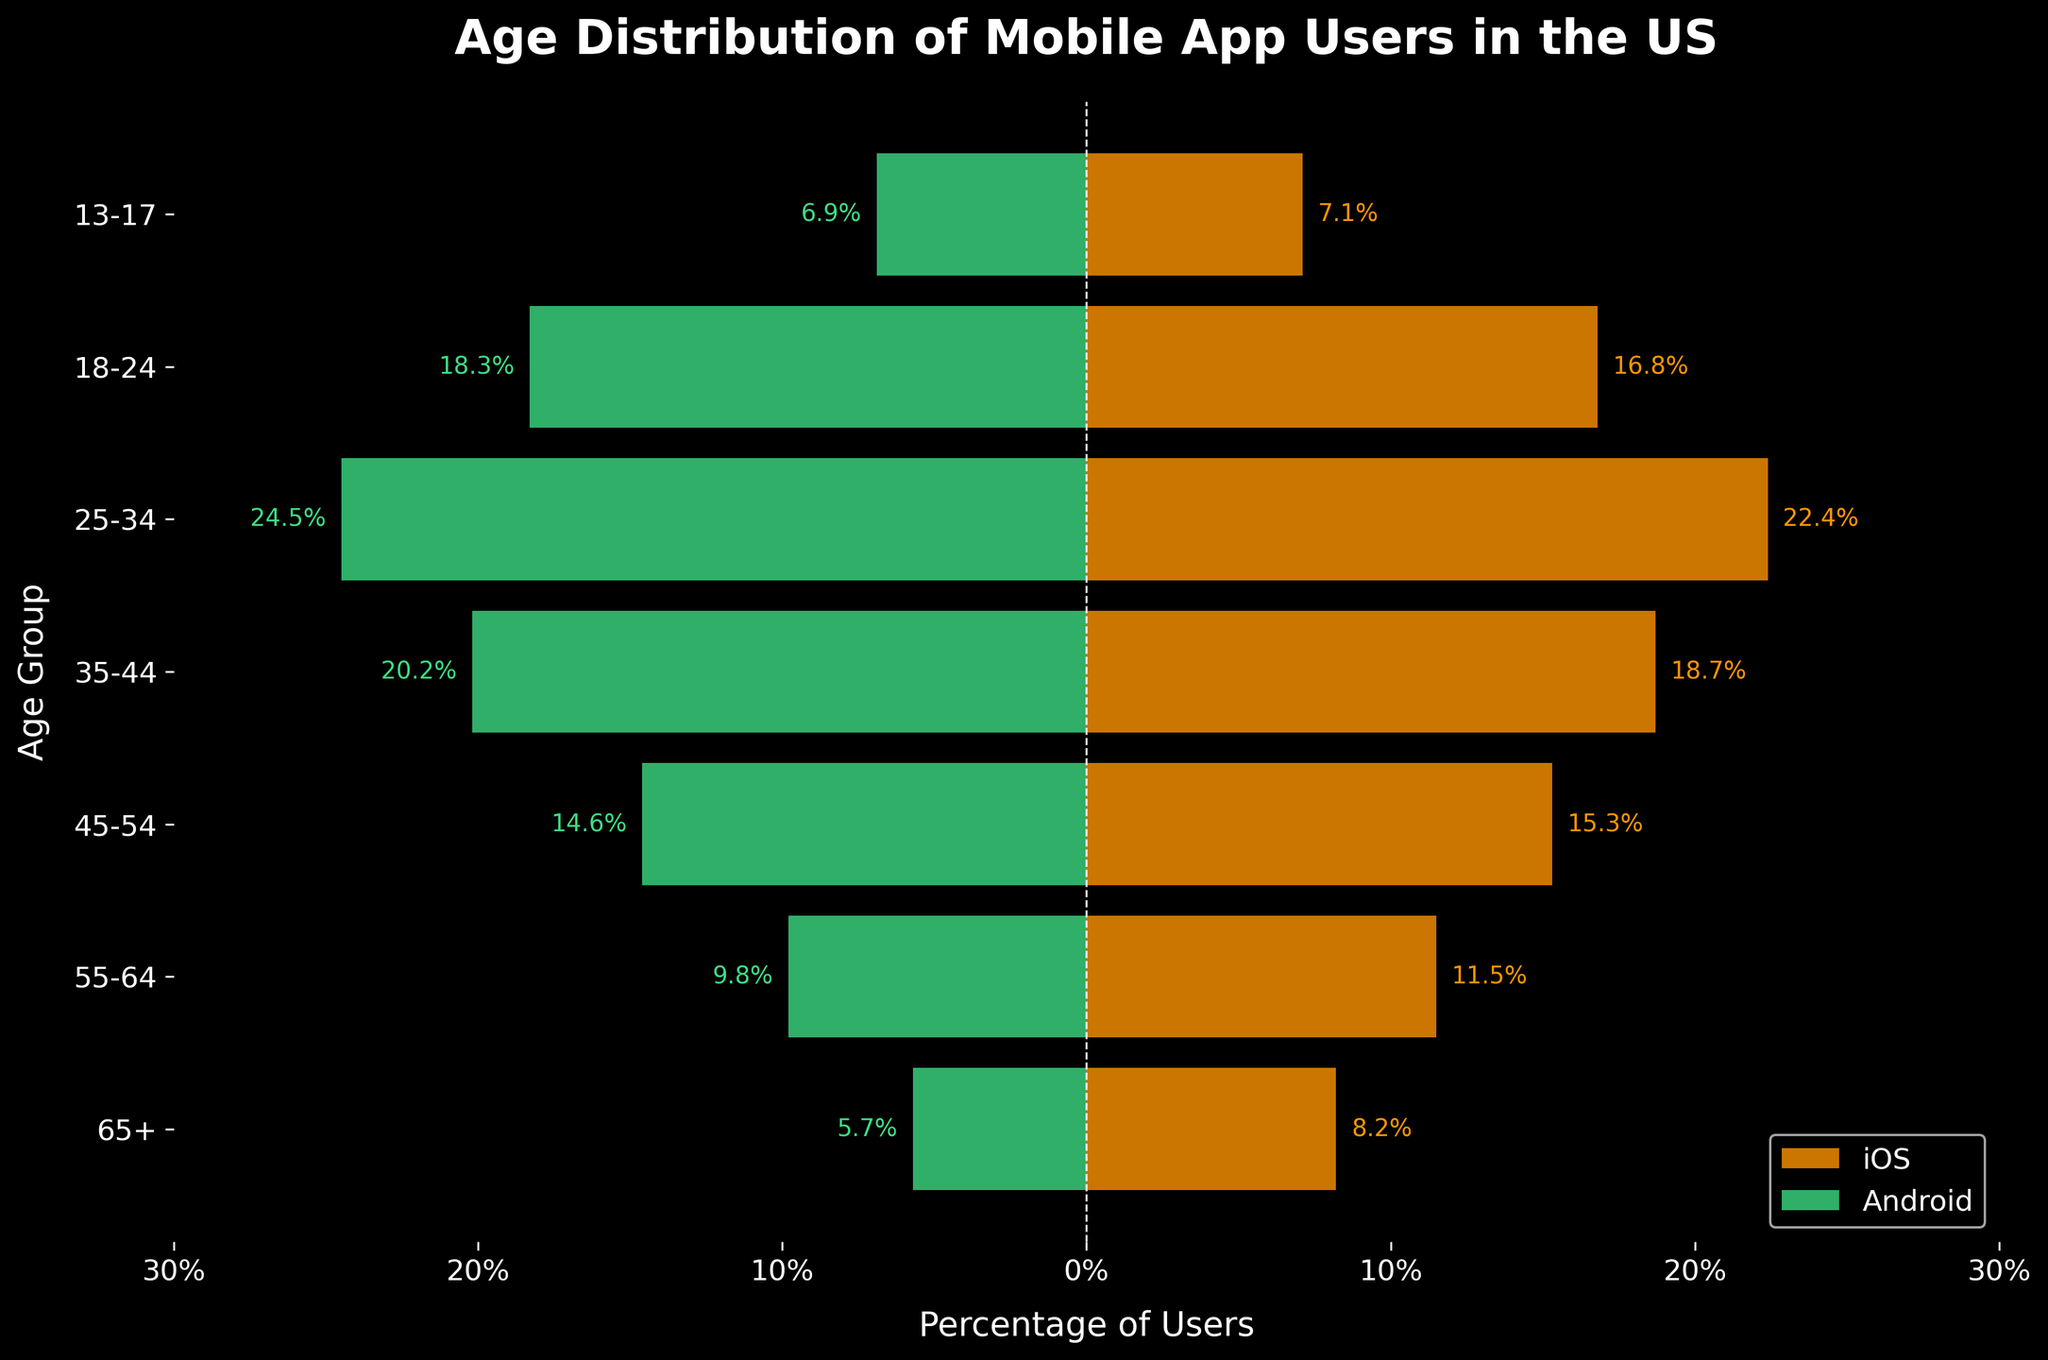What is the title of the plot? The title of the plot is usually displayed at the top of the figure. In this case, we see "Age Distribution of Mobile App Users in the US" at the top in a bold font.
Answer: Age Distribution of Mobile App Users in the US Which age group has the highest percentage of iOS users? By looking at the orange bars representing iOS users, the longest bar corresponds to the "25-34" age group, indicating it has the highest percentage.
Answer: 25-34 How does the percentage of Android users in the "18-24" age group compare to iOS users in the same group? The green bar for Android users in the "18-24" age group is slightly longer than the orange bar for iOS users, indicating a higher percentage of Android users in this group.
Answer: Android users have a higher percentage What is the percentage difference between iOS and Android users in the "55-64" age group? In the "55-64" age group, iOS users are at 11.5% while Android users are at 9.8%. The difference is calculated as 11.5% - 9.8% = 1.7%.
Answer: 1.7% Which age group has the smallest gap between the percentage of iOS and Android users? Examining the bars for each age group, the "45-54" age group has the smallest difference where iOS is at 15.3% and Android is at 14.6%, making the gap 0.7%.
Answer: 45-54 How many age groups have a higher percentage of Android users compared to iOS users? By visually comparing the length of the green and orange bars, the "35-44", "25-34", and "18-24" age groups have longer green bars. So, there are 3 age groups with a higher percentage of Android users.
Answer: 3 What is the total percentage of iOS users in the "55-64" and "65+" age groups combined? Summing up the percentages for these age groups: 11.5% (55-64) + 8.2% (65+) = 19.7%.
Answer: 19.7% What can you infer about the age distributions of mobile app users on iOS and Android? The majority of both iOS and Android users are concentrated in the middle age groups, particularly "25-34" and "35-44". However, Android has a slightly higher percentage in these younger age groups ("18-24", "25-34") while iOS has a higher percentage in older age groups ("55-64", "65+").
Answer: iOS has more older users; Android has more younger users Which age group has the closest percentages between iOS and Android users? The "45-54" age group shows iOS at 15.3% and Android at 14.6%, making their percentages the closest among all age groups, with only a 0.7% difference.
Answer: 45-54 